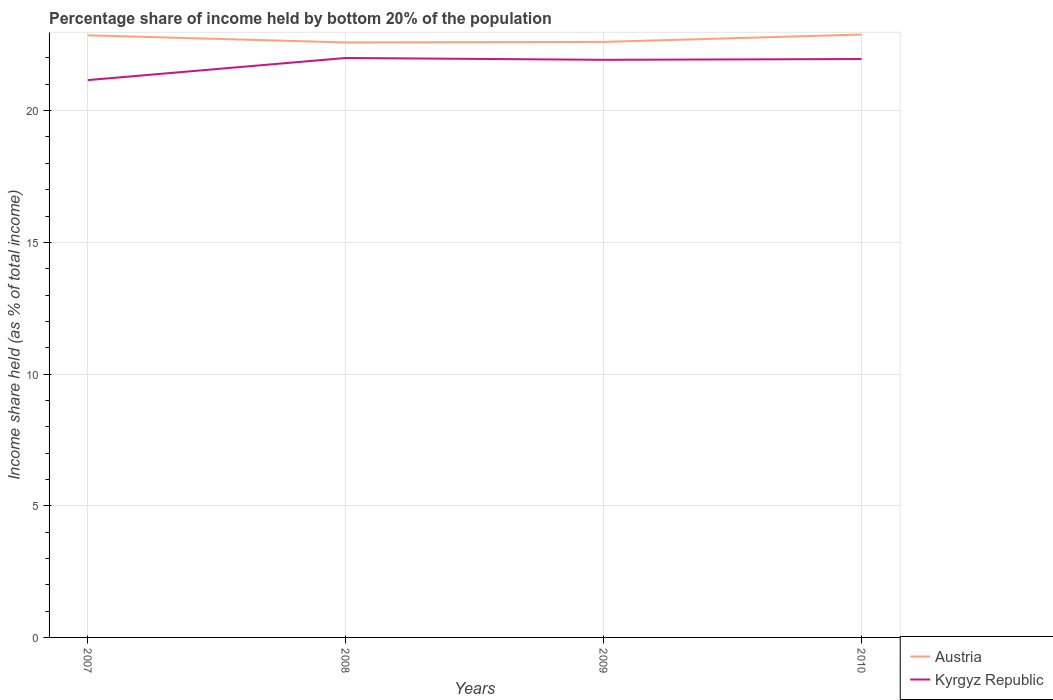How many different coloured lines are there?
Give a very brief answer. 2. Does the line corresponding to Kyrgyz Republic intersect with the line corresponding to Austria?
Make the answer very short. No. Across all years, what is the maximum share of income held by bottom 20% of the population in Austria?
Give a very brief answer. 22.59. In which year was the share of income held by bottom 20% of the population in Kyrgyz Republic maximum?
Offer a very short reply. 2007. What is the total share of income held by bottom 20% of the population in Kyrgyz Republic in the graph?
Keep it short and to the point. -0.8. What is the difference between the highest and the second highest share of income held by bottom 20% of the population in Kyrgyz Republic?
Provide a short and direct response. 0.84. Is the share of income held by bottom 20% of the population in Austria strictly greater than the share of income held by bottom 20% of the population in Kyrgyz Republic over the years?
Provide a succinct answer. No. How many lines are there?
Give a very brief answer. 2. What is the difference between two consecutive major ticks on the Y-axis?
Keep it short and to the point. 5. Are the values on the major ticks of Y-axis written in scientific E-notation?
Keep it short and to the point. No. Does the graph contain any zero values?
Ensure brevity in your answer.  No. Where does the legend appear in the graph?
Your response must be concise. Bottom right. How many legend labels are there?
Your response must be concise. 2. How are the legend labels stacked?
Make the answer very short. Vertical. What is the title of the graph?
Offer a terse response. Percentage share of income held by bottom 20% of the population. Does "Sint Maarten (Dutch part)" appear as one of the legend labels in the graph?
Provide a short and direct response. No. What is the label or title of the X-axis?
Offer a very short reply. Years. What is the label or title of the Y-axis?
Ensure brevity in your answer.  Income share held (as % of total income). What is the Income share held (as % of total income) of Austria in 2007?
Offer a terse response. 22.86. What is the Income share held (as % of total income) of Kyrgyz Republic in 2007?
Offer a terse response. 21.16. What is the Income share held (as % of total income) of Austria in 2008?
Provide a short and direct response. 22.59. What is the Income share held (as % of total income) in Austria in 2009?
Offer a terse response. 22.61. What is the Income share held (as % of total income) of Kyrgyz Republic in 2009?
Offer a very short reply. 21.93. What is the Income share held (as % of total income) of Austria in 2010?
Your answer should be compact. 22.89. What is the Income share held (as % of total income) in Kyrgyz Republic in 2010?
Your answer should be compact. 21.96. Across all years, what is the maximum Income share held (as % of total income) of Austria?
Your response must be concise. 22.89. Across all years, what is the minimum Income share held (as % of total income) of Austria?
Your answer should be very brief. 22.59. Across all years, what is the minimum Income share held (as % of total income) of Kyrgyz Republic?
Offer a terse response. 21.16. What is the total Income share held (as % of total income) in Austria in the graph?
Offer a very short reply. 90.95. What is the total Income share held (as % of total income) in Kyrgyz Republic in the graph?
Provide a short and direct response. 87.05. What is the difference between the Income share held (as % of total income) in Austria in 2007 and that in 2008?
Ensure brevity in your answer.  0.27. What is the difference between the Income share held (as % of total income) of Kyrgyz Republic in 2007 and that in 2008?
Provide a succinct answer. -0.84. What is the difference between the Income share held (as % of total income) in Kyrgyz Republic in 2007 and that in 2009?
Your response must be concise. -0.77. What is the difference between the Income share held (as % of total income) of Austria in 2007 and that in 2010?
Your answer should be very brief. -0.03. What is the difference between the Income share held (as % of total income) in Austria in 2008 and that in 2009?
Offer a terse response. -0.02. What is the difference between the Income share held (as % of total income) in Kyrgyz Republic in 2008 and that in 2009?
Your response must be concise. 0.07. What is the difference between the Income share held (as % of total income) of Austria in 2009 and that in 2010?
Offer a very short reply. -0.28. What is the difference between the Income share held (as % of total income) in Kyrgyz Republic in 2009 and that in 2010?
Ensure brevity in your answer.  -0.03. What is the difference between the Income share held (as % of total income) of Austria in 2007 and the Income share held (as % of total income) of Kyrgyz Republic in 2008?
Your response must be concise. 0.86. What is the difference between the Income share held (as % of total income) of Austria in 2007 and the Income share held (as % of total income) of Kyrgyz Republic in 2009?
Your answer should be very brief. 0.93. What is the difference between the Income share held (as % of total income) of Austria in 2008 and the Income share held (as % of total income) of Kyrgyz Republic in 2009?
Your answer should be very brief. 0.66. What is the difference between the Income share held (as % of total income) in Austria in 2008 and the Income share held (as % of total income) in Kyrgyz Republic in 2010?
Ensure brevity in your answer.  0.63. What is the difference between the Income share held (as % of total income) in Austria in 2009 and the Income share held (as % of total income) in Kyrgyz Republic in 2010?
Ensure brevity in your answer.  0.65. What is the average Income share held (as % of total income) of Austria per year?
Provide a succinct answer. 22.74. What is the average Income share held (as % of total income) of Kyrgyz Republic per year?
Offer a very short reply. 21.76. In the year 2007, what is the difference between the Income share held (as % of total income) of Austria and Income share held (as % of total income) of Kyrgyz Republic?
Ensure brevity in your answer.  1.7. In the year 2008, what is the difference between the Income share held (as % of total income) in Austria and Income share held (as % of total income) in Kyrgyz Republic?
Your answer should be very brief. 0.59. In the year 2009, what is the difference between the Income share held (as % of total income) of Austria and Income share held (as % of total income) of Kyrgyz Republic?
Offer a very short reply. 0.68. In the year 2010, what is the difference between the Income share held (as % of total income) in Austria and Income share held (as % of total income) in Kyrgyz Republic?
Your answer should be very brief. 0.93. What is the ratio of the Income share held (as % of total income) of Austria in 2007 to that in 2008?
Offer a terse response. 1.01. What is the ratio of the Income share held (as % of total income) of Kyrgyz Republic in 2007 to that in 2008?
Give a very brief answer. 0.96. What is the ratio of the Income share held (as % of total income) in Austria in 2007 to that in 2009?
Provide a succinct answer. 1.01. What is the ratio of the Income share held (as % of total income) in Kyrgyz Republic in 2007 to that in 2009?
Your answer should be very brief. 0.96. What is the ratio of the Income share held (as % of total income) of Kyrgyz Republic in 2007 to that in 2010?
Provide a succinct answer. 0.96. What is the ratio of the Income share held (as % of total income) of Austria in 2008 to that in 2009?
Your answer should be compact. 1. What is the ratio of the Income share held (as % of total income) of Kyrgyz Republic in 2008 to that in 2009?
Your answer should be very brief. 1. What is the ratio of the Income share held (as % of total income) of Austria in 2008 to that in 2010?
Make the answer very short. 0.99. What is the ratio of the Income share held (as % of total income) in Kyrgyz Republic in 2008 to that in 2010?
Provide a succinct answer. 1. What is the ratio of the Income share held (as % of total income) of Kyrgyz Republic in 2009 to that in 2010?
Provide a succinct answer. 1. What is the difference between the highest and the second highest Income share held (as % of total income) in Kyrgyz Republic?
Keep it short and to the point. 0.04. What is the difference between the highest and the lowest Income share held (as % of total income) of Kyrgyz Republic?
Your answer should be very brief. 0.84. 